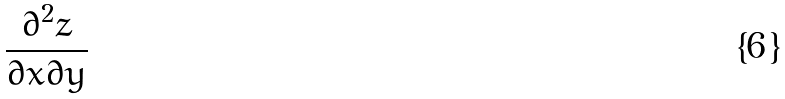Convert formula to latex. <formula><loc_0><loc_0><loc_500><loc_500>\frac { \partial ^ { 2 } z } { \partial x \partial y }</formula> 